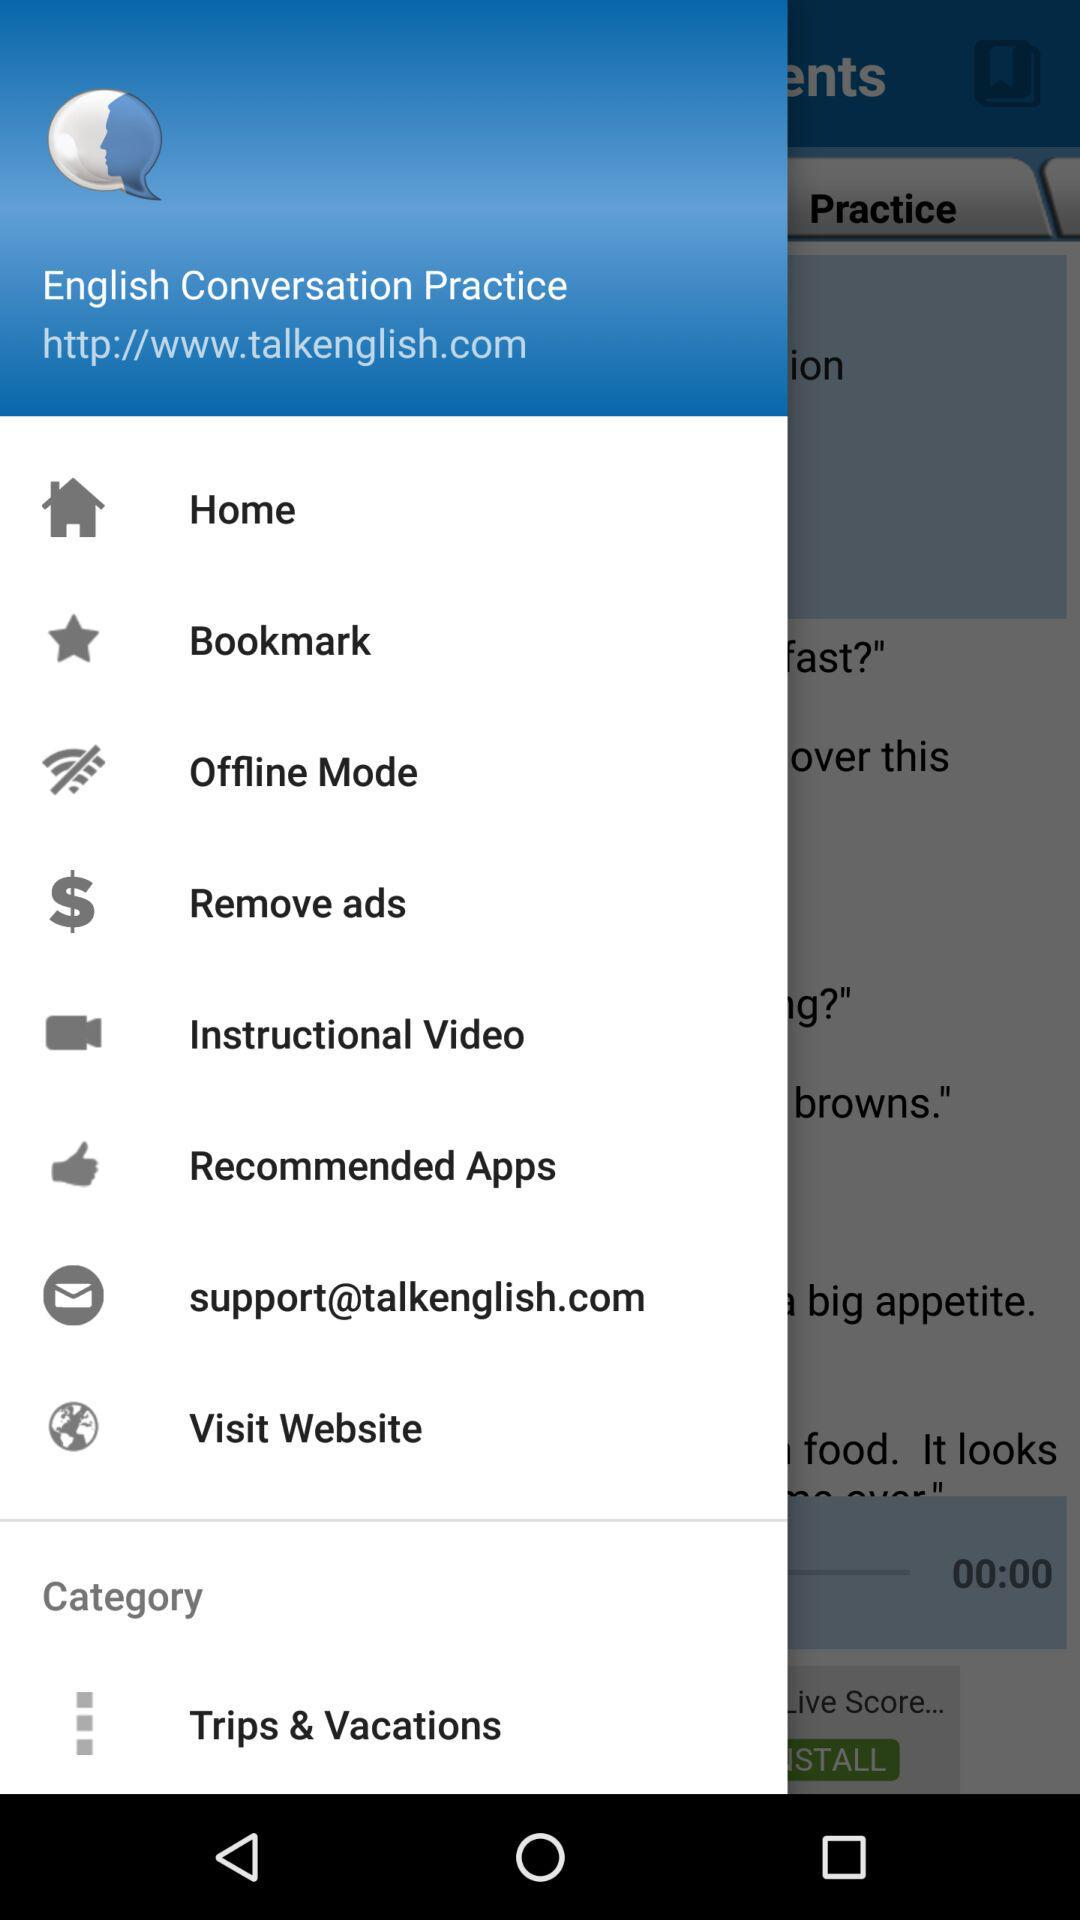What website can I visit for information about this application? The website is "http://www.talkenglish.com". 